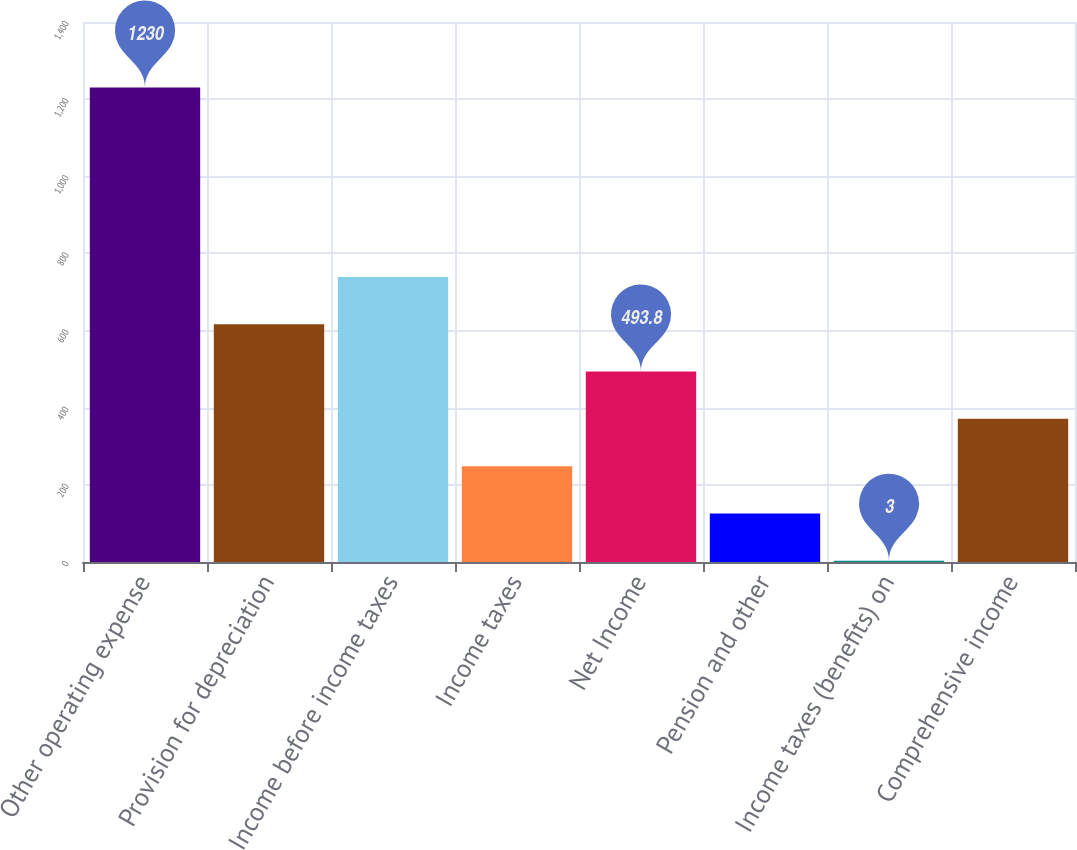<chart> <loc_0><loc_0><loc_500><loc_500><bar_chart><fcel>Other operating expense<fcel>Provision for depreciation<fcel>Income before income taxes<fcel>Income taxes<fcel>Net Income<fcel>Pension and other<fcel>Income taxes (benefits) on<fcel>Comprehensive income<nl><fcel>1230<fcel>616.5<fcel>739.2<fcel>248.4<fcel>493.8<fcel>125.7<fcel>3<fcel>371.1<nl></chart> 